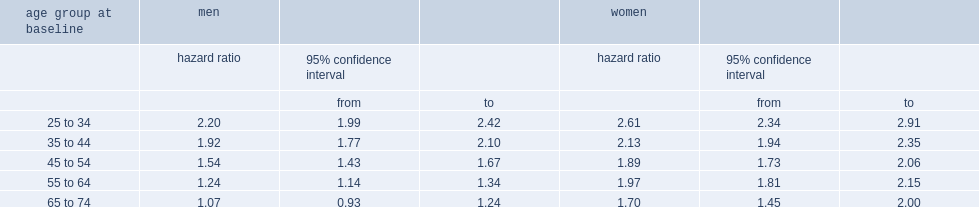For first nations cohort members aged 25 to 34 at baseline, what was the hazard ratio for men? 2.2. For first nations cohort members aged 25 to 34 at baseline, what was the hazard ratio for women? 2.61. At ages 65 to 74, the hazard ratio for which sex of first nations was lower? Men. 